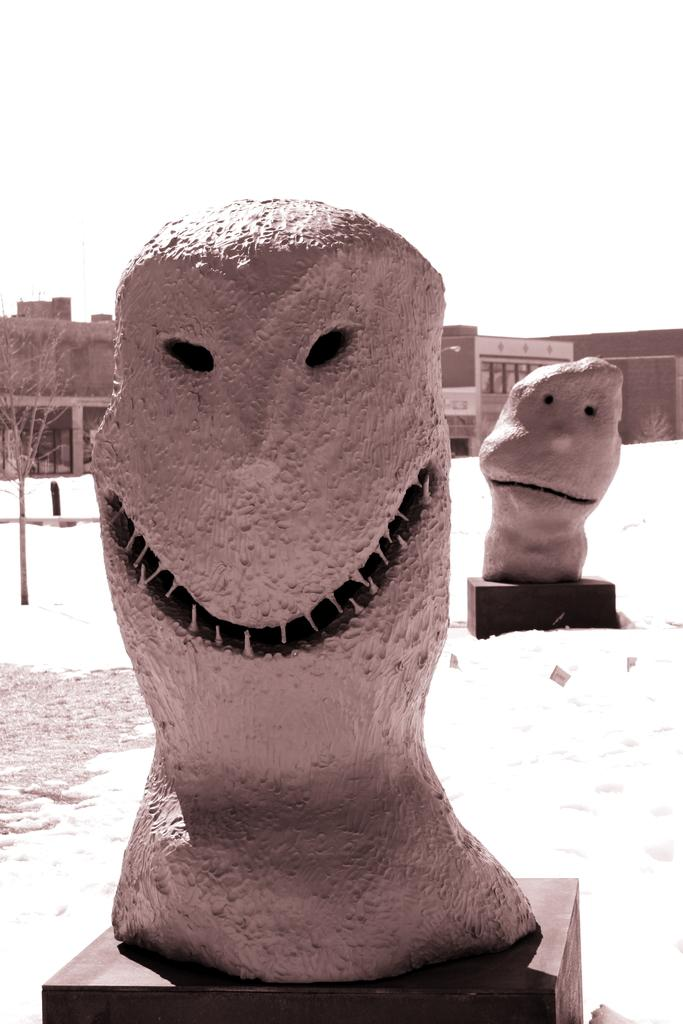How many sculptures can be seen in the image? There are two sculptures in the image. What other structures are present in the image? There are houses in the image. What celestial bodies are visible in the image? There are planets visible in the image. What part of the natural environment is visible in the image? The sky is visible in the image. What type of scent can be detected coming from the crowd in the image? There is no crowd present in the image, so it is not possible to determine any scent. 